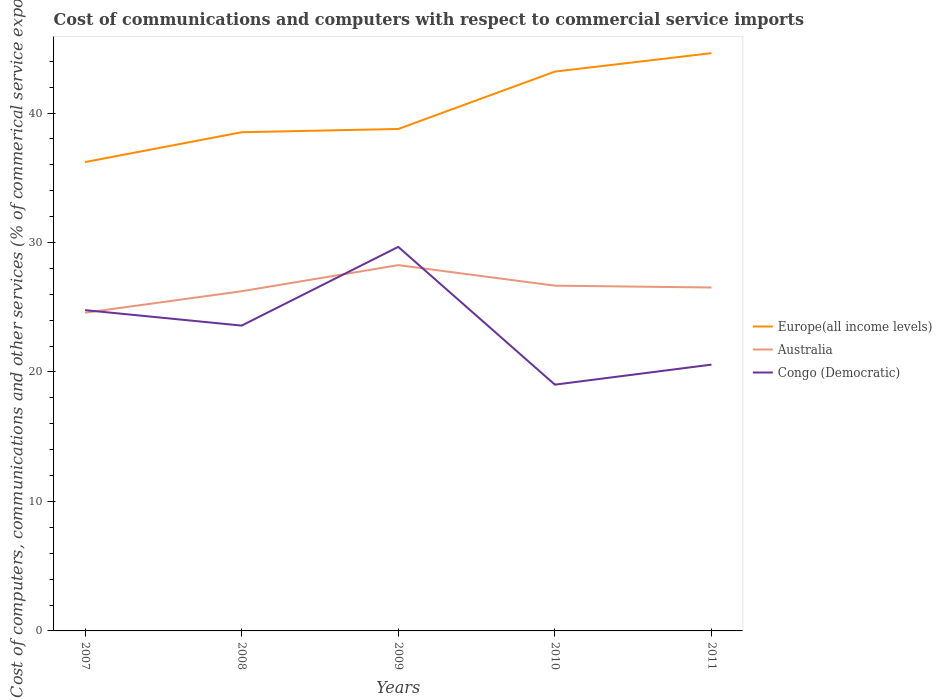Does the line corresponding to Europe(all income levels) intersect with the line corresponding to Australia?
Give a very brief answer. No. Across all years, what is the maximum cost of communications and computers in Europe(all income levels)?
Keep it short and to the point. 36.21. In which year was the cost of communications and computers in Europe(all income levels) maximum?
Give a very brief answer. 2007. What is the total cost of communications and computers in Congo (Democratic) in the graph?
Your answer should be compact. 1.19. What is the difference between the highest and the second highest cost of communications and computers in Congo (Democratic)?
Offer a very short reply. 10.64. How many lines are there?
Offer a very short reply. 3. How many years are there in the graph?
Give a very brief answer. 5. Are the values on the major ticks of Y-axis written in scientific E-notation?
Your answer should be very brief. No. Does the graph contain grids?
Keep it short and to the point. No. Where does the legend appear in the graph?
Your answer should be compact. Center right. What is the title of the graph?
Your response must be concise. Cost of communications and computers with respect to commercial service imports. Does "Benin" appear as one of the legend labels in the graph?
Give a very brief answer. No. What is the label or title of the Y-axis?
Ensure brevity in your answer.  Cost of computers, communications and other services (% of commerical service exports). What is the Cost of computers, communications and other services (% of commerical service exports) in Europe(all income levels) in 2007?
Provide a short and direct response. 36.21. What is the Cost of computers, communications and other services (% of commerical service exports) of Australia in 2007?
Your answer should be very brief. 24.58. What is the Cost of computers, communications and other services (% of commerical service exports) of Congo (Democratic) in 2007?
Provide a short and direct response. 24.78. What is the Cost of computers, communications and other services (% of commerical service exports) in Europe(all income levels) in 2008?
Provide a succinct answer. 38.52. What is the Cost of computers, communications and other services (% of commerical service exports) of Australia in 2008?
Ensure brevity in your answer.  26.24. What is the Cost of computers, communications and other services (% of commerical service exports) in Congo (Democratic) in 2008?
Your response must be concise. 23.58. What is the Cost of computers, communications and other services (% of commerical service exports) of Europe(all income levels) in 2009?
Provide a short and direct response. 38.77. What is the Cost of computers, communications and other services (% of commerical service exports) of Australia in 2009?
Your response must be concise. 28.25. What is the Cost of computers, communications and other services (% of commerical service exports) in Congo (Democratic) in 2009?
Make the answer very short. 29.66. What is the Cost of computers, communications and other services (% of commerical service exports) in Europe(all income levels) in 2010?
Keep it short and to the point. 43.2. What is the Cost of computers, communications and other services (% of commerical service exports) of Australia in 2010?
Your response must be concise. 26.67. What is the Cost of computers, communications and other services (% of commerical service exports) in Congo (Democratic) in 2010?
Your response must be concise. 19.02. What is the Cost of computers, communications and other services (% of commerical service exports) of Europe(all income levels) in 2011?
Make the answer very short. 44.63. What is the Cost of computers, communications and other services (% of commerical service exports) in Australia in 2011?
Your answer should be compact. 26.53. What is the Cost of computers, communications and other services (% of commerical service exports) of Congo (Democratic) in 2011?
Your response must be concise. 20.57. Across all years, what is the maximum Cost of computers, communications and other services (% of commerical service exports) of Europe(all income levels)?
Provide a succinct answer. 44.63. Across all years, what is the maximum Cost of computers, communications and other services (% of commerical service exports) of Australia?
Offer a terse response. 28.25. Across all years, what is the maximum Cost of computers, communications and other services (% of commerical service exports) of Congo (Democratic)?
Ensure brevity in your answer.  29.66. Across all years, what is the minimum Cost of computers, communications and other services (% of commerical service exports) in Europe(all income levels)?
Offer a terse response. 36.21. Across all years, what is the minimum Cost of computers, communications and other services (% of commerical service exports) of Australia?
Make the answer very short. 24.58. Across all years, what is the minimum Cost of computers, communications and other services (% of commerical service exports) in Congo (Democratic)?
Ensure brevity in your answer.  19.02. What is the total Cost of computers, communications and other services (% of commerical service exports) of Europe(all income levels) in the graph?
Provide a succinct answer. 201.34. What is the total Cost of computers, communications and other services (% of commerical service exports) in Australia in the graph?
Your answer should be compact. 132.26. What is the total Cost of computers, communications and other services (% of commerical service exports) in Congo (Democratic) in the graph?
Your response must be concise. 117.62. What is the difference between the Cost of computers, communications and other services (% of commerical service exports) in Europe(all income levels) in 2007 and that in 2008?
Offer a terse response. -2.31. What is the difference between the Cost of computers, communications and other services (% of commerical service exports) of Australia in 2007 and that in 2008?
Your answer should be very brief. -1.66. What is the difference between the Cost of computers, communications and other services (% of commerical service exports) of Congo (Democratic) in 2007 and that in 2008?
Offer a very short reply. 1.19. What is the difference between the Cost of computers, communications and other services (% of commerical service exports) of Europe(all income levels) in 2007 and that in 2009?
Make the answer very short. -2.56. What is the difference between the Cost of computers, communications and other services (% of commerical service exports) of Australia in 2007 and that in 2009?
Ensure brevity in your answer.  -3.68. What is the difference between the Cost of computers, communications and other services (% of commerical service exports) in Congo (Democratic) in 2007 and that in 2009?
Give a very brief answer. -4.89. What is the difference between the Cost of computers, communications and other services (% of commerical service exports) in Europe(all income levels) in 2007 and that in 2010?
Provide a succinct answer. -6.99. What is the difference between the Cost of computers, communications and other services (% of commerical service exports) in Australia in 2007 and that in 2010?
Your answer should be compact. -2.09. What is the difference between the Cost of computers, communications and other services (% of commerical service exports) in Congo (Democratic) in 2007 and that in 2010?
Make the answer very short. 5.76. What is the difference between the Cost of computers, communications and other services (% of commerical service exports) of Europe(all income levels) in 2007 and that in 2011?
Your answer should be compact. -8.41. What is the difference between the Cost of computers, communications and other services (% of commerical service exports) of Australia in 2007 and that in 2011?
Make the answer very short. -1.95. What is the difference between the Cost of computers, communications and other services (% of commerical service exports) in Congo (Democratic) in 2007 and that in 2011?
Your response must be concise. 4.21. What is the difference between the Cost of computers, communications and other services (% of commerical service exports) of Europe(all income levels) in 2008 and that in 2009?
Offer a terse response. -0.25. What is the difference between the Cost of computers, communications and other services (% of commerical service exports) in Australia in 2008 and that in 2009?
Give a very brief answer. -2.02. What is the difference between the Cost of computers, communications and other services (% of commerical service exports) of Congo (Democratic) in 2008 and that in 2009?
Offer a terse response. -6.08. What is the difference between the Cost of computers, communications and other services (% of commerical service exports) in Europe(all income levels) in 2008 and that in 2010?
Offer a terse response. -4.68. What is the difference between the Cost of computers, communications and other services (% of commerical service exports) of Australia in 2008 and that in 2010?
Provide a short and direct response. -0.43. What is the difference between the Cost of computers, communications and other services (% of commerical service exports) in Congo (Democratic) in 2008 and that in 2010?
Keep it short and to the point. 4.56. What is the difference between the Cost of computers, communications and other services (% of commerical service exports) of Europe(all income levels) in 2008 and that in 2011?
Your response must be concise. -6.11. What is the difference between the Cost of computers, communications and other services (% of commerical service exports) in Australia in 2008 and that in 2011?
Offer a terse response. -0.29. What is the difference between the Cost of computers, communications and other services (% of commerical service exports) of Congo (Democratic) in 2008 and that in 2011?
Make the answer very short. 3.01. What is the difference between the Cost of computers, communications and other services (% of commerical service exports) of Europe(all income levels) in 2009 and that in 2010?
Provide a short and direct response. -4.43. What is the difference between the Cost of computers, communications and other services (% of commerical service exports) in Australia in 2009 and that in 2010?
Your answer should be compact. 1.59. What is the difference between the Cost of computers, communications and other services (% of commerical service exports) of Congo (Democratic) in 2009 and that in 2010?
Your answer should be compact. 10.64. What is the difference between the Cost of computers, communications and other services (% of commerical service exports) in Europe(all income levels) in 2009 and that in 2011?
Provide a short and direct response. -5.86. What is the difference between the Cost of computers, communications and other services (% of commerical service exports) in Australia in 2009 and that in 2011?
Offer a very short reply. 1.73. What is the difference between the Cost of computers, communications and other services (% of commerical service exports) in Congo (Democratic) in 2009 and that in 2011?
Your answer should be compact. 9.09. What is the difference between the Cost of computers, communications and other services (% of commerical service exports) in Europe(all income levels) in 2010 and that in 2011?
Keep it short and to the point. -1.43. What is the difference between the Cost of computers, communications and other services (% of commerical service exports) of Australia in 2010 and that in 2011?
Your response must be concise. 0.14. What is the difference between the Cost of computers, communications and other services (% of commerical service exports) in Congo (Democratic) in 2010 and that in 2011?
Give a very brief answer. -1.55. What is the difference between the Cost of computers, communications and other services (% of commerical service exports) of Europe(all income levels) in 2007 and the Cost of computers, communications and other services (% of commerical service exports) of Australia in 2008?
Your answer should be compact. 9.98. What is the difference between the Cost of computers, communications and other services (% of commerical service exports) in Europe(all income levels) in 2007 and the Cost of computers, communications and other services (% of commerical service exports) in Congo (Democratic) in 2008?
Keep it short and to the point. 12.63. What is the difference between the Cost of computers, communications and other services (% of commerical service exports) of Australia in 2007 and the Cost of computers, communications and other services (% of commerical service exports) of Congo (Democratic) in 2008?
Offer a terse response. 0.99. What is the difference between the Cost of computers, communications and other services (% of commerical service exports) in Europe(all income levels) in 2007 and the Cost of computers, communications and other services (% of commerical service exports) in Australia in 2009?
Your answer should be very brief. 7.96. What is the difference between the Cost of computers, communications and other services (% of commerical service exports) of Europe(all income levels) in 2007 and the Cost of computers, communications and other services (% of commerical service exports) of Congo (Democratic) in 2009?
Offer a terse response. 6.55. What is the difference between the Cost of computers, communications and other services (% of commerical service exports) of Australia in 2007 and the Cost of computers, communications and other services (% of commerical service exports) of Congo (Democratic) in 2009?
Keep it short and to the point. -5.09. What is the difference between the Cost of computers, communications and other services (% of commerical service exports) of Europe(all income levels) in 2007 and the Cost of computers, communications and other services (% of commerical service exports) of Australia in 2010?
Ensure brevity in your answer.  9.55. What is the difference between the Cost of computers, communications and other services (% of commerical service exports) in Europe(all income levels) in 2007 and the Cost of computers, communications and other services (% of commerical service exports) in Congo (Democratic) in 2010?
Your answer should be very brief. 17.19. What is the difference between the Cost of computers, communications and other services (% of commerical service exports) in Australia in 2007 and the Cost of computers, communications and other services (% of commerical service exports) in Congo (Democratic) in 2010?
Ensure brevity in your answer.  5.56. What is the difference between the Cost of computers, communications and other services (% of commerical service exports) in Europe(all income levels) in 2007 and the Cost of computers, communications and other services (% of commerical service exports) in Australia in 2011?
Give a very brief answer. 9.69. What is the difference between the Cost of computers, communications and other services (% of commerical service exports) of Europe(all income levels) in 2007 and the Cost of computers, communications and other services (% of commerical service exports) of Congo (Democratic) in 2011?
Offer a very short reply. 15.64. What is the difference between the Cost of computers, communications and other services (% of commerical service exports) in Australia in 2007 and the Cost of computers, communications and other services (% of commerical service exports) in Congo (Democratic) in 2011?
Provide a short and direct response. 4.01. What is the difference between the Cost of computers, communications and other services (% of commerical service exports) of Europe(all income levels) in 2008 and the Cost of computers, communications and other services (% of commerical service exports) of Australia in 2009?
Make the answer very short. 10.27. What is the difference between the Cost of computers, communications and other services (% of commerical service exports) of Europe(all income levels) in 2008 and the Cost of computers, communications and other services (% of commerical service exports) of Congo (Democratic) in 2009?
Give a very brief answer. 8.86. What is the difference between the Cost of computers, communications and other services (% of commerical service exports) of Australia in 2008 and the Cost of computers, communications and other services (% of commerical service exports) of Congo (Democratic) in 2009?
Your answer should be very brief. -3.43. What is the difference between the Cost of computers, communications and other services (% of commerical service exports) in Europe(all income levels) in 2008 and the Cost of computers, communications and other services (% of commerical service exports) in Australia in 2010?
Provide a succinct answer. 11.85. What is the difference between the Cost of computers, communications and other services (% of commerical service exports) of Europe(all income levels) in 2008 and the Cost of computers, communications and other services (% of commerical service exports) of Congo (Democratic) in 2010?
Provide a short and direct response. 19.5. What is the difference between the Cost of computers, communications and other services (% of commerical service exports) in Australia in 2008 and the Cost of computers, communications and other services (% of commerical service exports) in Congo (Democratic) in 2010?
Your response must be concise. 7.22. What is the difference between the Cost of computers, communications and other services (% of commerical service exports) in Europe(all income levels) in 2008 and the Cost of computers, communications and other services (% of commerical service exports) in Australia in 2011?
Provide a succinct answer. 11.99. What is the difference between the Cost of computers, communications and other services (% of commerical service exports) in Europe(all income levels) in 2008 and the Cost of computers, communications and other services (% of commerical service exports) in Congo (Democratic) in 2011?
Provide a short and direct response. 17.95. What is the difference between the Cost of computers, communications and other services (% of commerical service exports) of Australia in 2008 and the Cost of computers, communications and other services (% of commerical service exports) of Congo (Democratic) in 2011?
Give a very brief answer. 5.67. What is the difference between the Cost of computers, communications and other services (% of commerical service exports) of Europe(all income levels) in 2009 and the Cost of computers, communications and other services (% of commerical service exports) of Australia in 2010?
Give a very brief answer. 12.1. What is the difference between the Cost of computers, communications and other services (% of commerical service exports) of Europe(all income levels) in 2009 and the Cost of computers, communications and other services (% of commerical service exports) of Congo (Democratic) in 2010?
Your answer should be compact. 19.75. What is the difference between the Cost of computers, communications and other services (% of commerical service exports) in Australia in 2009 and the Cost of computers, communications and other services (% of commerical service exports) in Congo (Democratic) in 2010?
Your answer should be very brief. 9.23. What is the difference between the Cost of computers, communications and other services (% of commerical service exports) of Europe(all income levels) in 2009 and the Cost of computers, communications and other services (% of commerical service exports) of Australia in 2011?
Keep it short and to the point. 12.24. What is the difference between the Cost of computers, communications and other services (% of commerical service exports) in Europe(all income levels) in 2009 and the Cost of computers, communications and other services (% of commerical service exports) in Congo (Democratic) in 2011?
Ensure brevity in your answer.  18.2. What is the difference between the Cost of computers, communications and other services (% of commerical service exports) in Australia in 2009 and the Cost of computers, communications and other services (% of commerical service exports) in Congo (Democratic) in 2011?
Offer a terse response. 7.68. What is the difference between the Cost of computers, communications and other services (% of commerical service exports) of Europe(all income levels) in 2010 and the Cost of computers, communications and other services (% of commerical service exports) of Australia in 2011?
Provide a short and direct response. 16.68. What is the difference between the Cost of computers, communications and other services (% of commerical service exports) in Europe(all income levels) in 2010 and the Cost of computers, communications and other services (% of commerical service exports) in Congo (Democratic) in 2011?
Offer a very short reply. 22.63. What is the difference between the Cost of computers, communications and other services (% of commerical service exports) of Australia in 2010 and the Cost of computers, communications and other services (% of commerical service exports) of Congo (Democratic) in 2011?
Give a very brief answer. 6.1. What is the average Cost of computers, communications and other services (% of commerical service exports) of Europe(all income levels) per year?
Offer a terse response. 40.27. What is the average Cost of computers, communications and other services (% of commerical service exports) in Australia per year?
Offer a terse response. 26.45. What is the average Cost of computers, communications and other services (% of commerical service exports) in Congo (Democratic) per year?
Provide a short and direct response. 23.52. In the year 2007, what is the difference between the Cost of computers, communications and other services (% of commerical service exports) of Europe(all income levels) and Cost of computers, communications and other services (% of commerical service exports) of Australia?
Your response must be concise. 11.64. In the year 2007, what is the difference between the Cost of computers, communications and other services (% of commerical service exports) in Europe(all income levels) and Cost of computers, communications and other services (% of commerical service exports) in Congo (Democratic)?
Provide a succinct answer. 11.44. In the year 2007, what is the difference between the Cost of computers, communications and other services (% of commerical service exports) of Australia and Cost of computers, communications and other services (% of commerical service exports) of Congo (Democratic)?
Give a very brief answer. -0.2. In the year 2008, what is the difference between the Cost of computers, communications and other services (% of commerical service exports) of Europe(all income levels) and Cost of computers, communications and other services (% of commerical service exports) of Australia?
Offer a terse response. 12.28. In the year 2008, what is the difference between the Cost of computers, communications and other services (% of commerical service exports) of Europe(all income levels) and Cost of computers, communications and other services (% of commerical service exports) of Congo (Democratic)?
Offer a very short reply. 14.94. In the year 2008, what is the difference between the Cost of computers, communications and other services (% of commerical service exports) in Australia and Cost of computers, communications and other services (% of commerical service exports) in Congo (Democratic)?
Provide a short and direct response. 2.65. In the year 2009, what is the difference between the Cost of computers, communications and other services (% of commerical service exports) of Europe(all income levels) and Cost of computers, communications and other services (% of commerical service exports) of Australia?
Keep it short and to the point. 10.52. In the year 2009, what is the difference between the Cost of computers, communications and other services (% of commerical service exports) of Europe(all income levels) and Cost of computers, communications and other services (% of commerical service exports) of Congo (Democratic)?
Give a very brief answer. 9.11. In the year 2009, what is the difference between the Cost of computers, communications and other services (% of commerical service exports) in Australia and Cost of computers, communications and other services (% of commerical service exports) in Congo (Democratic)?
Offer a very short reply. -1.41. In the year 2010, what is the difference between the Cost of computers, communications and other services (% of commerical service exports) of Europe(all income levels) and Cost of computers, communications and other services (% of commerical service exports) of Australia?
Ensure brevity in your answer.  16.54. In the year 2010, what is the difference between the Cost of computers, communications and other services (% of commerical service exports) in Europe(all income levels) and Cost of computers, communications and other services (% of commerical service exports) in Congo (Democratic)?
Ensure brevity in your answer.  24.18. In the year 2010, what is the difference between the Cost of computers, communications and other services (% of commerical service exports) in Australia and Cost of computers, communications and other services (% of commerical service exports) in Congo (Democratic)?
Your answer should be very brief. 7.65. In the year 2011, what is the difference between the Cost of computers, communications and other services (% of commerical service exports) of Europe(all income levels) and Cost of computers, communications and other services (% of commerical service exports) of Australia?
Your answer should be very brief. 18.1. In the year 2011, what is the difference between the Cost of computers, communications and other services (% of commerical service exports) in Europe(all income levels) and Cost of computers, communications and other services (% of commerical service exports) in Congo (Democratic)?
Your response must be concise. 24.06. In the year 2011, what is the difference between the Cost of computers, communications and other services (% of commerical service exports) in Australia and Cost of computers, communications and other services (% of commerical service exports) in Congo (Democratic)?
Make the answer very short. 5.96. What is the ratio of the Cost of computers, communications and other services (% of commerical service exports) in Europe(all income levels) in 2007 to that in 2008?
Your response must be concise. 0.94. What is the ratio of the Cost of computers, communications and other services (% of commerical service exports) of Australia in 2007 to that in 2008?
Offer a very short reply. 0.94. What is the ratio of the Cost of computers, communications and other services (% of commerical service exports) of Congo (Democratic) in 2007 to that in 2008?
Offer a terse response. 1.05. What is the ratio of the Cost of computers, communications and other services (% of commerical service exports) of Europe(all income levels) in 2007 to that in 2009?
Offer a very short reply. 0.93. What is the ratio of the Cost of computers, communications and other services (% of commerical service exports) in Australia in 2007 to that in 2009?
Offer a very short reply. 0.87. What is the ratio of the Cost of computers, communications and other services (% of commerical service exports) of Congo (Democratic) in 2007 to that in 2009?
Offer a terse response. 0.84. What is the ratio of the Cost of computers, communications and other services (% of commerical service exports) in Europe(all income levels) in 2007 to that in 2010?
Give a very brief answer. 0.84. What is the ratio of the Cost of computers, communications and other services (% of commerical service exports) in Australia in 2007 to that in 2010?
Your answer should be compact. 0.92. What is the ratio of the Cost of computers, communications and other services (% of commerical service exports) of Congo (Democratic) in 2007 to that in 2010?
Provide a succinct answer. 1.3. What is the ratio of the Cost of computers, communications and other services (% of commerical service exports) of Europe(all income levels) in 2007 to that in 2011?
Your answer should be compact. 0.81. What is the ratio of the Cost of computers, communications and other services (% of commerical service exports) of Australia in 2007 to that in 2011?
Ensure brevity in your answer.  0.93. What is the ratio of the Cost of computers, communications and other services (% of commerical service exports) of Congo (Democratic) in 2007 to that in 2011?
Ensure brevity in your answer.  1.2. What is the ratio of the Cost of computers, communications and other services (% of commerical service exports) in Europe(all income levels) in 2008 to that in 2009?
Your answer should be compact. 0.99. What is the ratio of the Cost of computers, communications and other services (% of commerical service exports) in Congo (Democratic) in 2008 to that in 2009?
Your answer should be very brief. 0.8. What is the ratio of the Cost of computers, communications and other services (% of commerical service exports) of Europe(all income levels) in 2008 to that in 2010?
Make the answer very short. 0.89. What is the ratio of the Cost of computers, communications and other services (% of commerical service exports) in Australia in 2008 to that in 2010?
Keep it short and to the point. 0.98. What is the ratio of the Cost of computers, communications and other services (% of commerical service exports) in Congo (Democratic) in 2008 to that in 2010?
Offer a terse response. 1.24. What is the ratio of the Cost of computers, communications and other services (% of commerical service exports) of Europe(all income levels) in 2008 to that in 2011?
Provide a succinct answer. 0.86. What is the ratio of the Cost of computers, communications and other services (% of commerical service exports) in Australia in 2008 to that in 2011?
Your response must be concise. 0.99. What is the ratio of the Cost of computers, communications and other services (% of commerical service exports) in Congo (Democratic) in 2008 to that in 2011?
Offer a very short reply. 1.15. What is the ratio of the Cost of computers, communications and other services (% of commerical service exports) in Europe(all income levels) in 2009 to that in 2010?
Provide a succinct answer. 0.9. What is the ratio of the Cost of computers, communications and other services (% of commerical service exports) in Australia in 2009 to that in 2010?
Offer a very short reply. 1.06. What is the ratio of the Cost of computers, communications and other services (% of commerical service exports) in Congo (Democratic) in 2009 to that in 2010?
Provide a succinct answer. 1.56. What is the ratio of the Cost of computers, communications and other services (% of commerical service exports) of Europe(all income levels) in 2009 to that in 2011?
Provide a succinct answer. 0.87. What is the ratio of the Cost of computers, communications and other services (% of commerical service exports) in Australia in 2009 to that in 2011?
Your response must be concise. 1.07. What is the ratio of the Cost of computers, communications and other services (% of commerical service exports) in Congo (Democratic) in 2009 to that in 2011?
Offer a very short reply. 1.44. What is the ratio of the Cost of computers, communications and other services (% of commerical service exports) of Europe(all income levels) in 2010 to that in 2011?
Your answer should be compact. 0.97. What is the ratio of the Cost of computers, communications and other services (% of commerical service exports) in Congo (Democratic) in 2010 to that in 2011?
Provide a short and direct response. 0.92. What is the difference between the highest and the second highest Cost of computers, communications and other services (% of commerical service exports) in Europe(all income levels)?
Provide a succinct answer. 1.43. What is the difference between the highest and the second highest Cost of computers, communications and other services (% of commerical service exports) in Australia?
Provide a succinct answer. 1.59. What is the difference between the highest and the second highest Cost of computers, communications and other services (% of commerical service exports) of Congo (Democratic)?
Offer a terse response. 4.89. What is the difference between the highest and the lowest Cost of computers, communications and other services (% of commerical service exports) in Europe(all income levels)?
Make the answer very short. 8.41. What is the difference between the highest and the lowest Cost of computers, communications and other services (% of commerical service exports) of Australia?
Provide a short and direct response. 3.68. What is the difference between the highest and the lowest Cost of computers, communications and other services (% of commerical service exports) in Congo (Democratic)?
Ensure brevity in your answer.  10.64. 